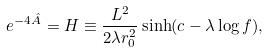Convert formula to latex. <formula><loc_0><loc_0><loc_500><loc_500>e ^ { - 4 \hat { A } } = H \equiv \frac { L ^ { 2 } } { 2 \lambda r _ { 0 } ^ { 2 } } \sinh ( c - \lambda \log f ) ,</formula> 